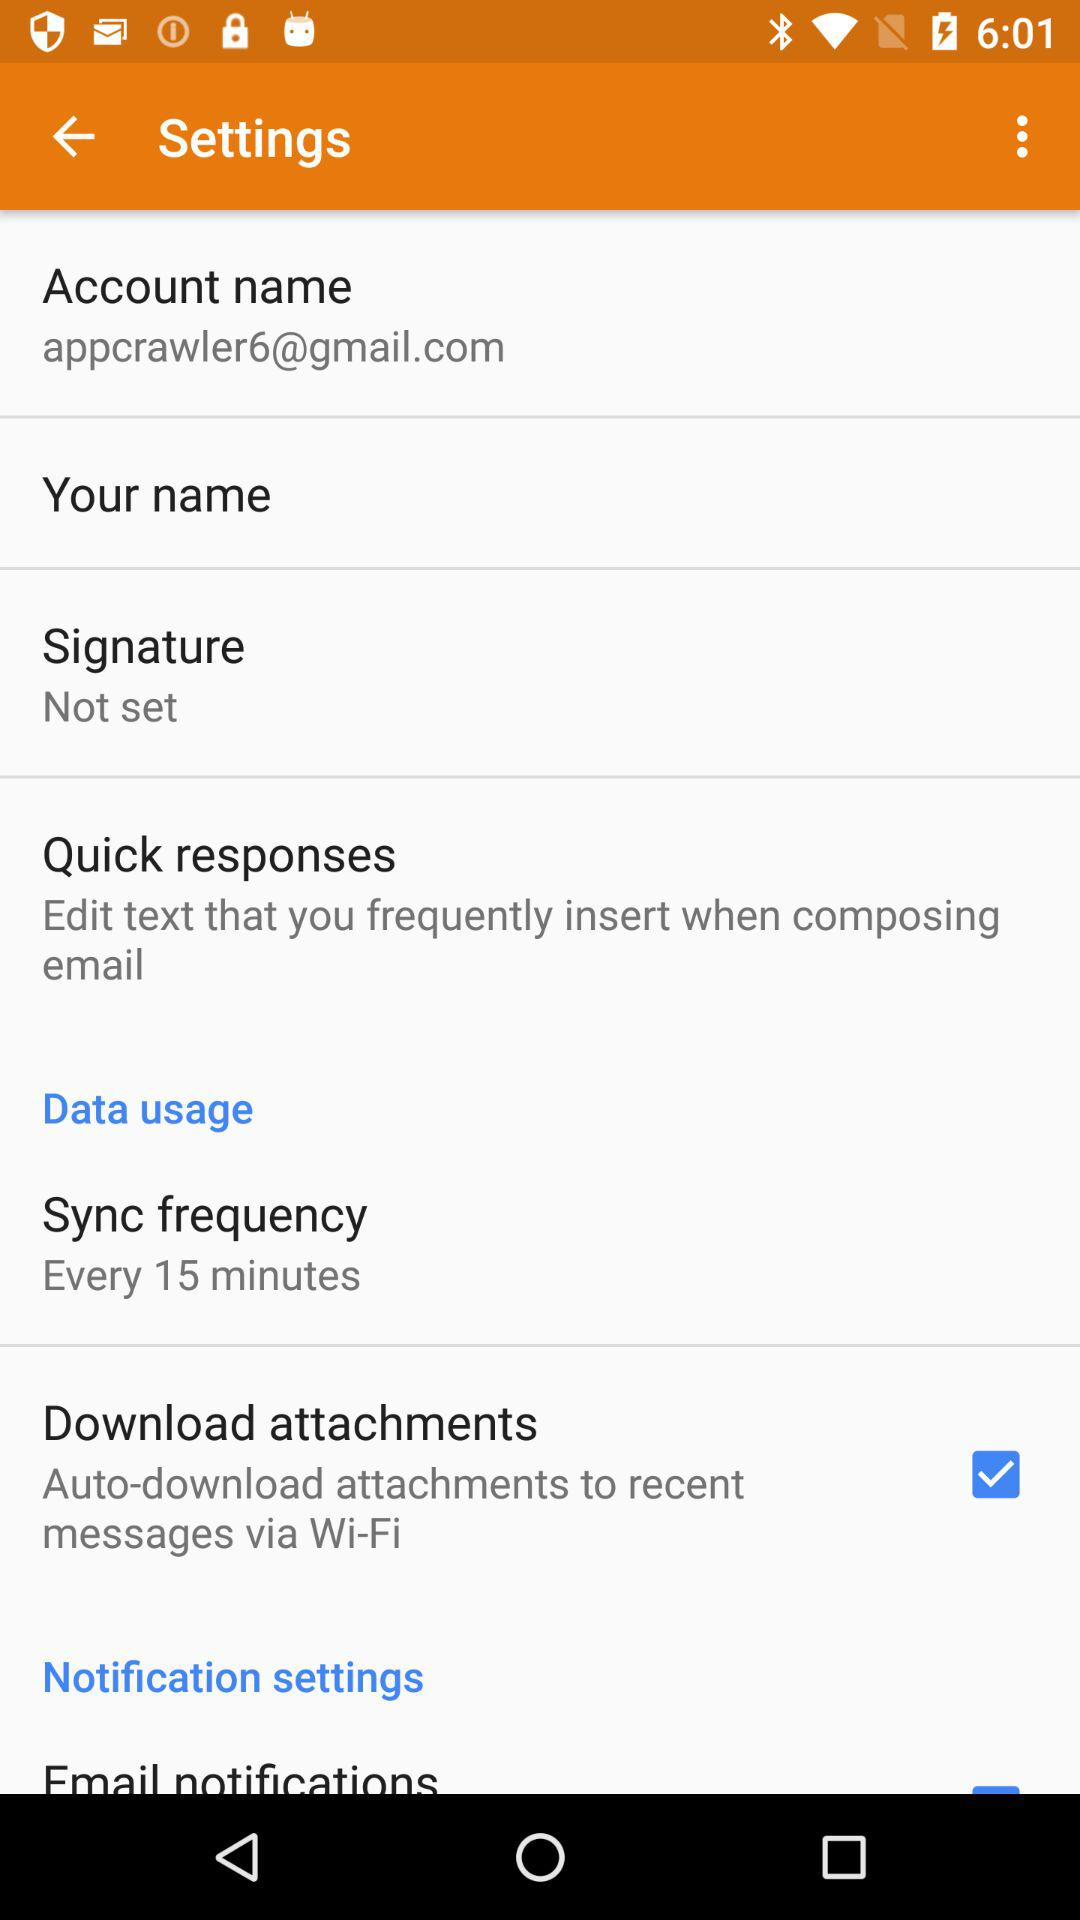What is the email address? The email address is appcrawler6@gmail.com. 